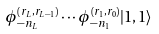Convert formula to latex. <formula><loc_0><loc_0><loc_500><loc_500>\phi ^ { ( r _ { L } , r _ { L - 1 } ) } _ { - n _ { L } } \cdots \phi ^ { ( r _ { 1 } , r _ { 0 } ) } _ { - n _ { 1 } } | 1 , 1 \rangle</formula> 